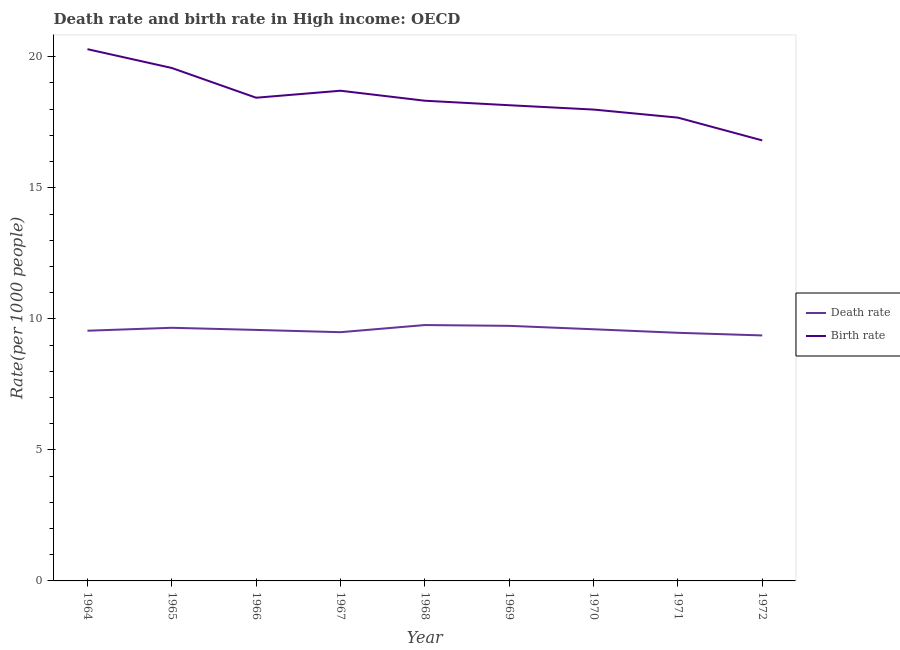Does the line corresponding to death rate intersect with the line corresponding to birth rate?
Give a very brief answer. No. Is the number of lines equal to the number of legend labels?
Offer a very short reply. Yes. What is the death rate in 1971?
Keep it short and to the point. 9.47. Across all years, what is the maximum birth rate?
Offer a terse response. 20.29. Across all years, what is the minimum death rate?
Your answer should be compact. 9.37. In which year was the death rate maximum?
Offer a very short reply. 1968. In which year was the death rate minimum?
Your response must be concise. 1972. What is the total birth rate in the graph?
Provide a succinct answer. 165.95. What is the difference between the death rate in 1967 and that in 1968?
Offer a very short reply. -0.27. What is the difference between the death rate in 1969 and the birth rate in 1967?
Your answer should be very brief. -8.97. What is the average death rate per year?
Ensure brevity in your answer.  9.58. In the year 1972, what is the difference between the birth rate and death rate?
Provide a short and direct response. 7.44. What is the ratio of the birth rate in 1964 to that in 1970?
Provide a short and direct response. 1.13. Is the birth rate in 1964 less than that in 1968?
Keep it short and to the point. No. What is the difference between the highest and the second highest death rate?
Your response must be concise. 0.03. What is the difference between the highest and the lowest death rate?
Provide a short and direct response. 0.4. Is the sum of the birth rate in 1965 and 1967 greater than the maximum death rate across all years?
Offer a very short reply. Yes. Does the death rate monotonically increase over the years?
Provide a short and direct response. No. Is the death rate strictly greater than the birth rate over the years?
Ensure brevity in your answer.  No. How many years are there in the graph?
Provide a succinct answer. 9. Are the values on the major ticks of Y-axis written in scientific E-notation?
Provide a succinct answer. No. Does the graph contain grids?
Your answer should be very brief. No. Where does the legend appear in the graph?
Your answer should be very brief. Center right. How many legend labels are there?
Provide a short and direct response. 2. What is the title of the graph?
Make the answer very short. Death rate and birth rate in High income: OECD. What is the label or title of the Y-axis?
Your answer should be compact. Rate(per 1000 people). What is the Rate(per 1000 people) in Death rate in 1964?
Provide a short and direct response. 9.55. What is the Rate(per 1000 people) in Birth rate in 1964?
Offer a very short reply. 20.29. What is the Rate(per 1000 people) in Death rate in 1965?
Your answer should be compact. 9.66. What is the Rate(per 1000 people) in Birth rate in 1965?
Provide a short and direct response. 19.57. What is the Rate(per 1000 people) of Death rate in 1966?
Provide a short and direct response. 9.58. What is the Rate(per 1000 people) in Birth rate in 1966?
Provide a succinct answer. 18.44. What is the Rate(per 1000 people) in Death rate in 1967?
Offer a very short reply. 9.49. What is the Rate(per 1000 people) of Birth rate in 1967?
Keep it short and to the point. 18.7. What is the Rate(per 1000 people) of Death rate in 1968?
Give a very brief answer. 9.76. What is the Rate(per 1000 people) in Birth rate in 1968?
Your answer should be compact. 18.32. What is the Rate(per 1000 people) of Death rate in 1969?
Keep it short and to the point. 9.73. What is the Rate(per 1000 people) in Birth rate in 1969?
Offer a terse response. 18.15. What is the Rate(per 1000 people) in Death rate in 1970?
Give a very brief answer. 9.6. What is the Rate(per 1000 people) of Birth rate in 1970?
Provide a short and direct response. 17.99. What is the Rate(per 1000 people) in Death rate in 1971?
Provide a short and direct response. 9.47. What is the Rate(per 1000 people) in Birth rate in 1971?
Make the answer very short. 17.68. What is the Rate(per 1000 people) of Death rate in 1972?
Your response must be concise. 9.37. What is the Rate(per 1000 people) in Birth rate in 1972?
Keep it short and to the point. 16.81. Across all years, what is the maximum Rate(per 1000 people) of Death rate?
Your answer should be compact. 9.76. Across all years, what is the maximum Rate(per 1000 people) of Birth rate?
Offer a terse response. 20.29. Across all years, what is the minimum Rate(per 1000 people) of Death rate?
Your answer should be compact. 9.37. Across all years, what is the minimum Rate(per 1000 people) in Birth rate?
Keep it short and to the point. 16.81. What is the total Rate(per 1000 people) in Death rate in the graph?
Your response must be concise. 86.21. What is the total Rate(per 1000 people) of Birth rate in the graph?
Offer a very short reply. 165.95. What is the difference between the Rate(per 1000 people) in Death rate in 1964 and that in 1965?
Your answer should be very brief. -0.11. What is the difference between the Rate(per 1000 people) in Birth rate in 1964 and that in 1965?
Give a very brief answer. 0.72. What is the difference between the Rate(per 1000 people) in Death rate in 1964 and that in 1966?
Provide a succinct answer. -0.03. What is the difference between the Rate(per 1000 people) of Birth rate in 1964 and that in 1966?
Make the answer very short. 1.85. What is the difference between the Rate(per 1000 people) of Death rate in 1964 and that in 1967?
Offer a very short reply. 0.06. What is the difference between the Rate(per 1000 people) of Birth rate in 1964 and that in 1967?
Your answer should be very brief. 1.59. What is the difference between the Rate(per 1000 people) in Death rate in 1964 and that in 1968?
Keep it short and to the point. -0.22. What is the difference between the Rate(per 1000 people) of Birth rate in 1964 and that in 1968?
Give a very brief answer. 1.97. What is the difference between the Rate(per 1000 people) of Death rate in 1964 and that in 1969?
Your response must be concise. -0.19. What is the difference between the Rate(per 1000 people) in Birth rate in 1964 and that in 1969?
Offer a terse response. 2.14. What is the difference between the Rate(per 1000 people) of Death rate in 1964 and that in 1970?
Offer a terse response. -0.06. What is the difference between the Rate(per 1000 people) in Birth rate in 1964 and that in 1970?
Offer a very short reply. 2.3. What is the difference between the Rate(per 1000 people) in Death rate in 1964 and that in 1971?
Offer a very short reply. 0.08. What is the difference between the Rate(per 1000 people) in Birth rate in 1964 and that in 1971?
Your answer should be compact. 2.61. What is the difference between the Rate(per 1000 people) of Death rate in 1964 and that in 1972?
Keep it short and to the point. 0.18. What is the difference between the Rate(per 1000 people) in Birth rate in 1964 and that in 1972?
Your response must be concise. 3.48. What is the difference between the Rate(per 1000 people) of Death rate in 1965 and that in 1966?
Provide a short and direct response. 0.08. What is the difference between the Rate(per 1000 people) in Birth rate in 1965 and that in 1966?
Provide a succinct answer. 1.13. What is the difference between the Rate(per 1000 people) in Death rate in 1965 and that in 1967?
Keep it short and to the point. 0.17. What is the difference between the Rate(per 1000 people) in Birth rate in 1965 and that in 1967?
Ensure brevity in your answer.  0.87. What is the difference between the Rate(per 1000 people) in Death rate in 1965 and that in 1968?
Your answer should be very brief. -0.1. What is the difference between the Rate(per 1000 people) of Birth rate in 1965 and that in 1968?
Offer a very short reply. 1.25. What is the difference between the Rate(per 1000 people) of Death rate in 1965 and that in 1969?
Provide a succinct answer. -0.07. What is the difference between the Rate(per 1000 people) of Birth rate in 1965 and that in 1969?
Provide a short and direct response. 1.42. What is the difference between the Rate(per 1000 people) of Death rate in 1965 and that in 1970?
Your answer should be very brief. 0.06. What is the difference between the Rate(per 1000 people) of Birth rate in 1965 and that in 1970?
Your response must be concise. 1.59. What is the difference between the Rate(per 1000 people) in Death rate in 1965 and that in 1971?
Give a very brief answer. 0.19. What is the difference between the Rate(per 1000 people) in Birth rate in 1965 and that in 1971?
Make the answer very short. 1.89. What is the difference between the Rate(per 1000 people) in Death rate in 1965 and that in 1972?
Make the answer very short. 0.29. What is the difference between the Rate(per 1000 people) of Birth rate in 1965 and that in 1972?
Your response must be concise. 2.76. What is the difference between the Rate(per 1000 people) of Death rate in 1966 and that in 1967?
Provide a short and direct response. 0.09. What is the difference between the Rate(per 1000 people) of Birth rate in 1966 and that in 1967?
Your answer should be compact. -0.27. What is the difference between the Rate(per 1000 people) of Death rate in 1966 and that in 1968?
Make the answer very short. -0.19. What is the difference between the Rate(per 1000 people) of Birth rate in 1966 and that in 1968?
Give a very brief answer. 0.11. What is the difference between the Rate(per 1000 people) of Death rate in 1966 and that in 1969?
Provide a succinct answer. -0.16. What is the difference between the Rate(per 1000 people) in Birth rate in 1966 and that in 1969?
Offer a terse response. 0.29. What is the difference between the Rate(per 1000 people) in Death rate in 1966 and that in 1970?
Provide a short and direct response. -0.02. What is the difference between the Rate(per 1000 people) in Birth rate in 1966 and that in 1970?
Offer a very short reply. 0.45. What is the difference between the Rate(per 1000 people) of Death rate in 1966 and that in 1971?
Ensure brevity in your answer.  0.11. What is the difference between the Rate(per 1000 people) in Birth rate in 1966 and that in 1971?
Ensure brevity in your answer.  0.76. What is the difference between the Rate(per 1000 people) in Death rate in 1966 and that in 1972?
Provide a short and direct response. 0.21. What is the difference between the Rate(per 1000 people) in Birth rate in 1966 and that in 1972?
Provide a short and direct response. 1.63. What is the difference between the Rate(per 1000 people) of Death rate in 1967 and that in 1968?
Provide a succinct answer. -0.27. What is the difference between the Rate(per 1000 people) in Birth rate in 1967 and that in 1968?
Keep it short and to the point. 0.38. What is the difference between the Rate(per 1000 people) in Death rate in 1967 and that in 1969?
Provide a succinct answer. -0.24. What is the difference between the Rate(per 1000 people) of Birth rate in 1967 and that in 1969?
Keep it short and to the point. 0.55. What is the difference between the Rate(per 1000 people) in Death rate in 1967 and that in 1970?
Your response must be concise. -0.11. What is the difference between the Rate(per 1000 people) of Birth rate in 1967 and that in 1970?
Your answer should be compact. 0.72. What is the difference between the Rate(per 1000 people) of Death rate in 1967 and that in 1971?
Your response must be concise. 0.02. What is the difference between the Rate(per 1000 people) in Birth rate in 1967 and that in 1971?
Your answer should be very brief. 1.03. What is the difference between the Rate(per 1000 people) in Death rate in 1967 and that in 1972?
Make the answer very short. 0.12. What is the difference between the Rate(per 1000 people) of Birth rate in 1967 and that in 1972?
Your response must be concise. 1.9. What is the difference between the Rate(per 1000 people) of Death rate in 1968 and that in 1969?
Your response must be concise. 0.03. What is the difference between the Rate(per 1000 people) in Birth rate in 1968 and that in 1969?
Your answer should be compact. 0.17. What is the difference between the Rate(per 1000 people) in Death rate in 1968 and that in 1970?
Provide a short and direct response. 0.16. What is the difference between the Rate(per 1000 people) in Birth rate in 1968 and that in 1970?
Your answer should be compact. 0.34. What is the difference between the Rate(per 1000 people) of Death rate in 1968 and that in 1971?
Your answer should be very brief. 0.3. What is the difference between the Rate(per 1000 people) in Birth rate in 1968 and that in 1971?
Keep it short and to the point. 0.64. What is the difference between the Rate(per 1000 people) in Death rate in 1968 and that in 1972?
Provide a short and direct response. 0.4. What is the difference between the Rate(per 1000 people) of Birth rate in 1968 and that in 1972?
Keep it short and to the point. 1.51. What is the difference between the Rate(per 1000 people) in Death rate in 1969 and that in 1970?
Your answer should be very brief. 0.13. What is the difference between the Rate(per 1000 people) of Birth rate in 1969 and that in 1970?
Give a very brief answer. 0.17. What is the difference between the Rate(per 1000 people) of Death rate in 1969 and that in 1971?
Make the answer very short. 0.27. What is the difference between the Rate(per 1000 people) in Birth rate in 1969 and that in 1971?
Ensure brevity in your answer.  0.47. What is the difference between the Rate(per 1000 people) in Death rate in 1969 and that in 1972?
Offer a very short reply. 0.37. What is the difference between the Rate(per 1000 people) of Birth rate in 1969 and that in 1972?
Your answer should be compact. 1.34. What is the difference between the Rate(per 1000 people) in Death rate in 1970 and that in 1971?
Your answer should be compact. 0.13. What is the difference between the Rate(per 1000 people) in Birth rate in 1970 and that in 1971?
Your answer should be compact. 0.31. What is the difference between the Rate(per 1000 people) in Death rate in 1970 and that in 1972?
Ensure brevity in your answer.  0.24. What is the difference between the Rate(per 1000 people) of Birth rate in 1970 and that in 1972?
Your response must be concise. 1.18. What is the difference between the Rate(per 1000 people) in Death rate in 1971 and that in 1972?
Provide a succinct answer. 0.1. What is the difference between the Rate(per 1000 people) of Birth rate in 1971 and that in 1972?
Make the answer very short. 0.87. What is the difference between the Rate(per 1000 people) of Death rate in 1964 and the Rate(per 1000 people) of Birth rate in 1965?
Offer a very short reply. -10.03. What is the difference between the Rate(per 1000 people) of Death rate in 1964 and the Rate(per 1000 people) of Birth rate in 1966?
Ensure brevity in your answer.  -8.89. What is the difference between the Rate(per 1000 people) in Death rate in 1964 and the Rate(per 1000 people) in Birth rate in 1967?
Your answer should be very brief. -9.16. What is the difference between the Rate(per 1000 people) in Death rate in 1964 and the Rate(per 1000 people) in Birth rate in 1968?
Ensure brevity in your answer.  -8.78. What is the difference between the Rate(per 1000 people) in Death rate in 1964 and the Rate(per 1000 people) in Birth rate in 1969?
Offer a terse response. -8.6. What is the difference between the Rate(per 1000 people) of Death rate in 1964 and the Rate(per 1000 people) of Birth rate in 1970?
Keep it short and to the point. -8.44. What is the difference between the Rate(per 1000 people) in Death rate in 1964 and the Rate(per 1000 people) in Birth rate in 1971?
Offer a terse response. -8.13. What is the difference between the Rate(per 1000 people) in Death rate in 1964 and the Rate(per 1000 people) in Birth rate in 1972?
Keep it short and to the point. -7.26. What is the difference between the Rate(per 1000 people) of Death rate in 1965 and the Rate(per 1000 people) of Birth rate in 1966?
Make the answer very short. -8.78. What is the difference between the Rate(per 1000 people) of Death rate in 1965 and the Rate(per 1000 people) of Birth rate in 1967?
Make the answer very short. -9.04. What is the difference between the Rate(per 1000 people) in Death rate in 1965 and the Rate(per 1000 people) in Birth rate in 1968?
Your response must be concise. -8.66. What is the difference between the Rate(per 1000 people) of Death rate in 1965 and the Rate(per 1000 people) of Birth rate in 1969?
Ensure brevity in your answer.  -8.49. What is the difference between the Rate(per 1000 people) in Death rate in 1965 and the Rate(per 1000 people) in Birth rate in 1970?
Provide a short and direct response. -8.33. What is the difference between the Rate(per 1000 people) in Death rate in 1965 and the Rate(per 1000 people) in Birth rate in 1971?
Provide a succinct answer. -8.02. What is the difference between the Rate(per 1000 people) in Death rate in 1965 and the Rate(per 1000 people) in Birth rate in 1972?
Keep it short and to the point. -7.15. What is the difference between the Rate(per 1000 people) of Death rate in 1966 and the Rate(per 1000 people) of Birth rate in 1967?
Your answer should be compact. -9.13. What is the difference between the Rate(per 1000 people) of Death rate in 1966 and the Rate(per 1000 people) of Birth rate in 1968?
Make the answer very short. -8.75. What is the difference between the Rate(per 1000 people) in Death rate in 1966 and the Rate(per 1000 people) in Birth rate in 1969?
Offer a very short reply. -8.57. What is the difference between the Rate(per 1000 people) of Death rate in 1966 and the Rate(per 1000 people) of Birth rate in 1970?
Keep it short and to the point. -8.41. What is the difference between the Rate(per 1000 people) of Death rate in 1966 and the Rate(per 1000 people) of Birth rate in 1971?
Offer a very short reply. -8.1. What is the difference between the Rate(per 1000 people) of Death rate in 1966 and the Rate(per 1000 people) of Birth rate in 1972?
Ensure brevity in your answer.  -7.23. What is the difference between the Rate(per 1000 people) in Death rate in 1967 and the Rate(per 1000 people) in Birth rate in 1968?
Keep it short and to the point. -8.83. What is the difference between the Rate(per 1000 people) in Death rate in 1967 and the Rate(per 1000 people) in Birth rate in 1969?
Your response must be concise. -8.66. What is the difference between the Rate(per 1000 people) in Death rate in 1967 and the Rate(per 1000 people) in Birth rate in 1970?
Your answer should be compact. -8.49. What is the difference between the Rate(per 1000 people) of Death rate in 1967 and the Rate(per 1000 people) of Birth rate in 1971?
Ensure brevity in your answer.  -8.19. What is the difference between the Rate(per 1000 people) in Death rate in 1967 and the Rate(per 1000 people) in Birth rate in 1972?
Your answer should be compact. -7.32. What is the difference between the Rate(per 1000 people) in Death rate in 1968 and the Rate(per 1000 people) in Birth rate in 1969?
Make the answer very short. -8.39. What is the difference between the Rate(per 1000 people) in Death rate in 1968 and the Rate(per 1000 people) in Birth rate in 1970?
Provide a short and direct response. -8.22. What is the difference between the Rate(per 1000 people) in Death rate in 1968 and the Rate(per 1000 people) in Birth rate in 1971?
Provide a succinct answer. -7.91. What is the difference between the Rate(per 1000 people) in Death rate in 1968 and the Rate(per 1000 people) in Birth rate in 1972?
Offer a very short reply. -7.05. What is the difference between the Rate(per 1000 people) of Death rate in 1969 and the Rate(per 1000 people) of Birth rate in 1970?
Ensure brevity in your answer.  -8.25. What is the difference between the Rate(per 1000 people) of Death rate in 1969 and the Rate(per 1000 people) of Birth rate in 1971?
Make the answer very short. -7.95. What is the difference between the Rate(per 1000 people) of Death rate in 1969 and the Rate(per 1000 people) of Birth rate in 1972?
Provide a succinct answer. -7.08. What is the difference between the Rate(per 1000 people) of Death rate in 1970 and the Rate(per 1000 people) of Birth rate in 1971?
Offer a terse response. -8.08. What is the difference between the Rate(per 1000 people) of Death rate in 1970 and the Rate(per 1000 people) of Birth rate in 1972?
Your response must be concise. -7.21. What is the difference between the Rate(per 1000 people) of Death rate in 1971 and the Rate(per 1000 people) of Birth rate in 1972?
Make the answer very short. -7.34. What is the average Rate(per 1000 people) in Death rate per year?
Your answer should be compact. 9.58. What is the average Rate(per 1000 people) in Birth rate per year?
Offer a terse response. 18.44. In the year 1964, what is the difference between the Rate(per 1000 people) of Death rate and Rate(per 1000 people) of Birth rate?
Give a very brief answer. -10.74. In the year 1965, what is the difference between the Rate(per 1000 people) of Death rate and Rate(per 1000 people) of Birth rate?
Provide a short and direct response. -9.91. In the year 1966, what is the difference between the Rate(per 1000 people) of Death rate and Rate(per 1000 people) of Birth rate?
Make the answer very short. -8.86. In the year 1967, what is the difference between the Rate(per 1000 people) of Death rate and Rate(per 1000 people) of Birth rate?
Ensure brevity in your answer.  -9.21. In the year 1968, what is the difference between the Rate(per 1000 people) of Death rate and Rate(per 1000 people) of Birth rate?
Offer a very short reply. -8.56. In the year 1969, what is the difference between the Rate(per 1000 people) of Death rate and Rate(per 1000 people) of Birth rate?
Make the answer very short. -8.42. In the year 1970, what is the difference between the Rate(per 1000 people) of Death rate and Rate(per 1000 people) of Birth rate?
Offer a very short reply. -8.38. In the year 1971, what is the difference between the Rate(per 1000 people) of Death rate and Rate(per 1000 people) of Birth rate?
Offer a very short reply. -8.21. In the year 1972, what is the difference between the Rate(per 1000 people) of Death rate and Rate(per 1000 people) of Birth rate?
Keep it short and to the point. -7.44. What is the ratio of the Rate(per 1000 people) in Death rate in 1964 to that in 1965?
Offer a very short reply. 0.99. What is the ratio of the Rate(per 1000 people) in Birth rate in 1964 to that in 1965?
Offer a very short reply. 1.04. What is the ratio of the Rate(per 1000 people) of Birth rate in 1964 to that in 1966?
Make the answer very short. 1.1. What is the ratio of the Rate(per 1000 people) of Death rate in 1964 to that in 1967?
Keep it short and to the point. 1.01. What is the ratio of the Rate(per 1000 people) in Birth rate in 1964 to that in 1967?
Make the answer very short. 1.08. What is the ratio of the Rate(per 1000 people) of Death rate in 1964 to that in 1968?
Keep it short and to the point. 0.98. What is the ratio of the Rate(per 1000 people) of Birth rate in 1964 to that in 1968?
Provide a short and direct response. 1.11. What is the ratio of the Rate(per 1000 people) of Death rate in 1964 to that in 1969?
Your answer should be compact. 0.98. What is the ratio of the Rate(per 1000 people) of Birth rate in 1964 to that in 1969?
Offer a very short reply. 1.12. What is the ratio of the Rate(per 1000 people) in Death rate in 1964 to that in 1970?
Your response must be concise. 0.99. What is the ratio of the Rate(per 1000 people) of Birth rate in 1964 to that in 1970?
Provide a short and direct response. 1.13. What is the ratio of the Rate(per 1000 people) in Death rate in 1964 to that in 1971?
Provide a succinct answer. 1.01. What is the ratio of the Rate(per 1000 people) in Birth rate in 1964 to that in 1971?
Your answer should be very brief. 1.15. What is the ratio of the Rate(per 1000 people) of Death rate in 1964 to that in 1972?
Keep it short and to the point. 1.02. What is the ratio of the Rate(per 1000 people) of Birth rate in 1964 to that in 1972?
Provide a short and direct response. 1.21. What is the ratio of the Rate(per 1000 people) of Death rate in 1965 to that in 1966?
Your answer should be very brief. 1.01. What is the ratio of the Rate(per 1000 people) of Birth rate in 1965 to that in 1966?
Your answer should be compact. 1.06. What is the ratio of the Rate(per 1000 people) of Death rate in 1965 to that in 1967?
Your answer should be very brief. 1.02. What is the ratio of the Rate(per 1000 people) in Birth rate in 1965 to that in 1967?
Offer a terse response. 1.05. What is the ratio of the Rate(per 1000 people) in Death rate in 1965 to that in 1968?
Provide a succinct answer. 0.99. What is the ratio of the Rate(per 1000 people) of Birth rate in 1965 to that in 1968?
Make the answer very short. 1.07. What is the ratio of the Rate(per 1000 people) in Death rate in 1965 to that in 1969?
Provide a succinct answer. 0.99. What is the ratio of the Rate(per 1000 people) in Birth rate in 1965 to that in 1969?
Provide a succinct answer. 1.08. What is the ratio of the Rate(per 1000 people) in Death rate in 1965 to that in 1970?
Make the answer very short. 1.01. What is the ratio of the Rate(per 1000 people) of Birth rate in 1965 to that in 1970?
Give a very brief answer. 1.09. What is the ratio of the Rate(per 1000 people) of Death rate in 1965 to that in 1971?
Provide a succinct answer. 1.02. What is the ratio of the Rate(per 1000 people) of Birth rate in 1965 to that in 1971?
Your response must be concise. 1.11. What is the ratio of the Rate(per 1000 people) in Death rate in 1965 to that in 1972?
Your response must be concise. 1.03. What is the ratio of the Rate(per 1000 people) in Birth rate in 1965 to that in 1972?
Your answer should be very brief. 1.16. What is the ratio of the Rate(per 1000 people) in Death rate in 1966 to that in 1967?
Offer a terse response. 1.01. What is the ratio of the Rate(per 1000 people) in Birth rate in 1966 to that in 1967?
Ensure brevity in your answer.  0.99. What is the ratio of the Rate(per 1000 people) of Death rate in 1966 to that in 1968?
Offer a very short reply. 0.98. What is the ratio of the Rate(per 1000 people) in Death rate in 1966 to that in 1969?
Provide a short and direct response. 0.98. What is the ratio of the Rate(per 1000 people) in Birth rate in 1966 to that in 1969?
Make the answer very short. 1.02. What is the ratio of the Rate(per 1000 people) of Death rate in 1966 to that in 1970?
Your answer should be compact. 1. What is the ratio of the Rate(per 1000 people) in Birth rate in 1966 to that in 1970?
Provide a short and direct response. 1.03. What is the ratio of the Rate(per 1000 people) of Death rate in 1966 to that in 1971?
Offer a terse response. 1.01. What is the ratio of the Rate(per 1000 people) in Birth rate in 1966 to that in 1971?
Your answer should be very brief. 1.04. What is the ratio of the Rate(per 1000 people) of Death rate in 1966 to that in 1972?
Offer a very short reply. 1.02. What is the ratio of the Rate(per 1000 people) of Birth rate in 1966 to that in 1972?
Make the answer very short. 1.1. What is the ratio of the Rate(per 1000 people) of Death rate in 1967 to that in 1968?
Make the answer very short. 0.97. What is the ratio of the Rate(per 1000 people) in Birth rate in 1967 to that in 1968?
Provide a short and direct response. 1.02. What is the ratio of the Rate(per 1000 people) of Death rate in 1967 to that in 1969?
Offer a very short reply. 0.98. What is the ratio of the Rate(per 1000 people) of Birth rate in 1967 to that in 1969?
Provide a short and direct response. 1.03. What is the ratio of the Rate(per 1000 people) in Death rate in 1967 to that in 1970?
Make the answer very short. 0.99. What is the ratio of the Rate(per 1000 people) of Birth rate in 1967 to that in 1970?
Keep it short and to the point. 1.04. What is the ratio of the Rate(per 1000 people) of Death rate in 1967 to that in 1971?
Keep it short and to the point. 1. What is the ratio of the Rate(per 1000 people) in Birth rate in 1967 to that in 1971?
Ensure brevity in your answer.  1.06. What is the ratio of the Rate(per 1000 people) in Death rate in 1967 to that in 1972?
Keep it short and to the point. 1.01. What is the ratio of the Rate(per 1000 people) in Birth rate in 1967 to that in 1972?
Make the answer very short. 1.11. What is the ratio of the Rate(per 1000 people) of Death rate in 1968 to that in 1969?
Make the answer very short. 1. What is the ratio of the Rate(per 1000 people) in Birth rate in 1968 to that in 1969?
Provide a succinct answer. 1.01. What is the ratio of the Rate(per 1000 people) of Death rate in 1968 to that in 1970?
Your answer should be compact. 1.02. What is the ratio of the Rate(per 1000 people) of Birth rate in 1968 to that in 1970?
Make the answer very short. 1.02. What is the ratio of the Rate(per 1000 people) of Death rate in 1968 to that in 1971?
Your response must be concise. 1.03. What is the ratio of the Rate(per 1000 people) of Birth rate in 1968 to that in 1971?
Your answer should be very brief. 1.04. What is the ratio of the Rate(per 1000 people) of Death rate in 1968 to that in 1972?
Offer a terse response. 1.04. What is the ratio of the Rate(per 1000 people) in Birth rate in 1968 to that in 1972?
Ensure brevity in your answer.  1.09. What is the ratio of the Rate(per 1000 people) of Death rate in 1969 to that in 1970?
Ensure brevity in your answer.  1.01. What is the ratio of the Rate(per 1000 people) of Birth rate in 1969 to that in 1970?
Your answer should be compact. 1.01. What is the ratio of the Rate(per 1000 people) in Death rate in 1969 to that in 1971?
Provide a short and direct response. 1.03. What is the ratio of the Rate(per 1000 people) of Birth rate in 1969 to that in 1971?
Provide a short and direct response. 1.03. What is the ratio of the Rate(per 1000 people) of Death rate in 1969 to that in 1972?
Keep it short and to the point. 1.04. What is the ratio of the Rate(per 1000 people) in Birth rate in 1969 to that in 1972?
Keep it short and to the point. 1.08. What is the ratio of the Rate(per 1000 people) of Death rate in 1970 to that in 1971?
Offer a very short reply. 1.01. What is the ratio of the Rate(per 1000 people) in Birth rate in 1970 to that in 1971?
Your answer should be compact. 1.02. What is the ratio of the Rate(per 1000 people) of Death rate in 1970 to that in 1972?
Keep it short and to the point. 1.03. What is the ratio of the Rate(per 1000 people) of Birth rate in 1970 to that in 1972?
Provide a succinct answer. 1.07. What is the ratio of the Rate(per 1000 people) in Death rate in 1971 to that in 1972?
Provide a succinct answer. 1.01. What is the ratio of the Rate(per 1000 people) of Birth rate in 1971 to that in 1972?
Your answer should be compact. 1.05. What is the difference between the highest and the second highest Rate(per 1000 people) in Death rate?
Your response must be concise. 0.03. What is the difference between the highest and the second highest Rate(per 1000 people) of Birth rate?
Give a very brief answer. 0.72. What is the difference between the highest and the lowest Rate(per 1000 people) of Death rate?
Provide a succinct answer. 0.4. What is the difference between the highest and the lowest Rate(per 1000 people) in Birth rate?
Make the answer very short. 3.48. 